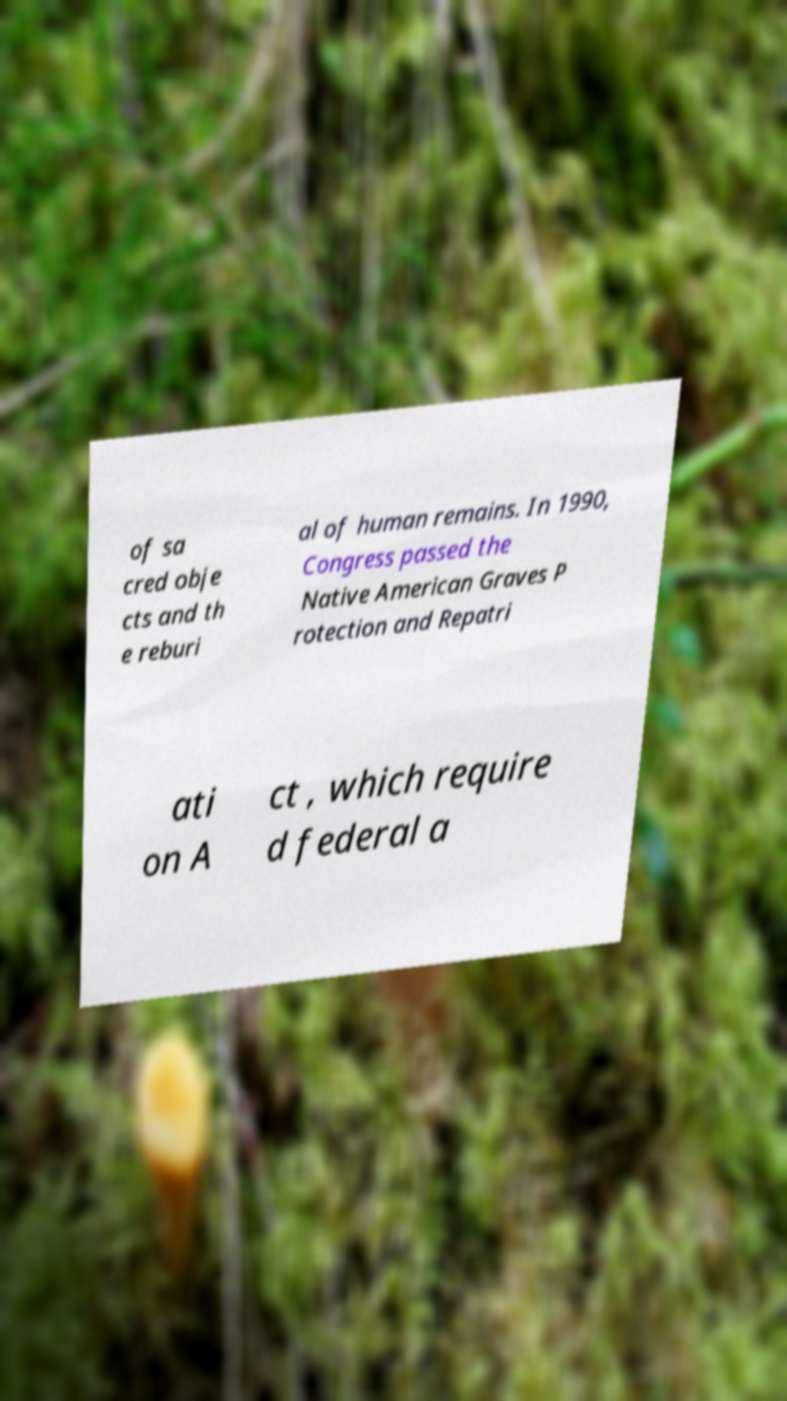Please read and relay the text visible in this image. What does it say? of sa cred obje cts and th e reburi al of human remains. In 1990, Congress passed the Native American Graves P rotection and Repatri ati on A ct , which require d federal a 